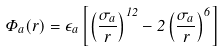Convert formula to latex. <formula><loc_0><loc_0><loc_500><loc_500>\Phi _ { a } ( r ) = \epsilon _ { a } \left [ \left ( \frac { \sigma _ { a } } { r } \right ) ^ { 1 2 } - 2 \left ( \frac { \sigma _ { a } } { r } \right ) ^ { 6 } \right ]</formula> 